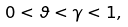Convert formula to latex. <formula><loc_0><loc_0><loc_500><loc_500>0 < \vartheta < \gamma < 1 ,</formula> 